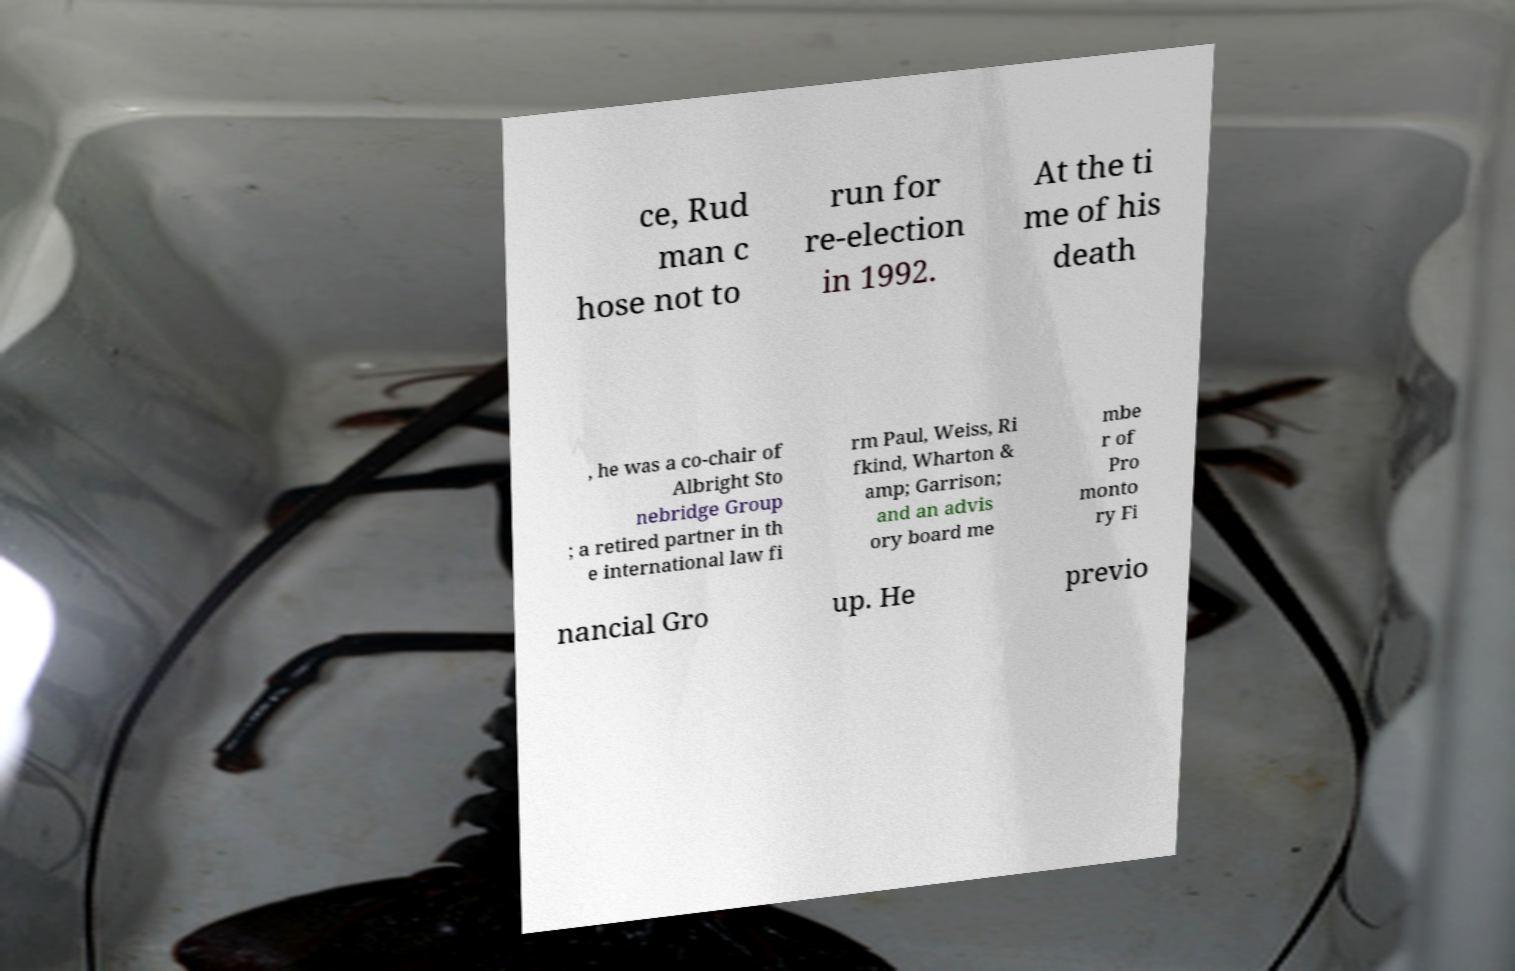Could you extract and type out the text from this image? ce, Rud man c hose not to run for re-election in 1992. At the ti me of his death , he was a co-chair of Albright Sto nebridge Group ; a retired partner in th e international law fi rm Paul, Weiss, Ri fkind, Wharton & amp; Garrison; and an advis ory board me mbe r of Pro monto ry Fi nancial Gro up. He previo 